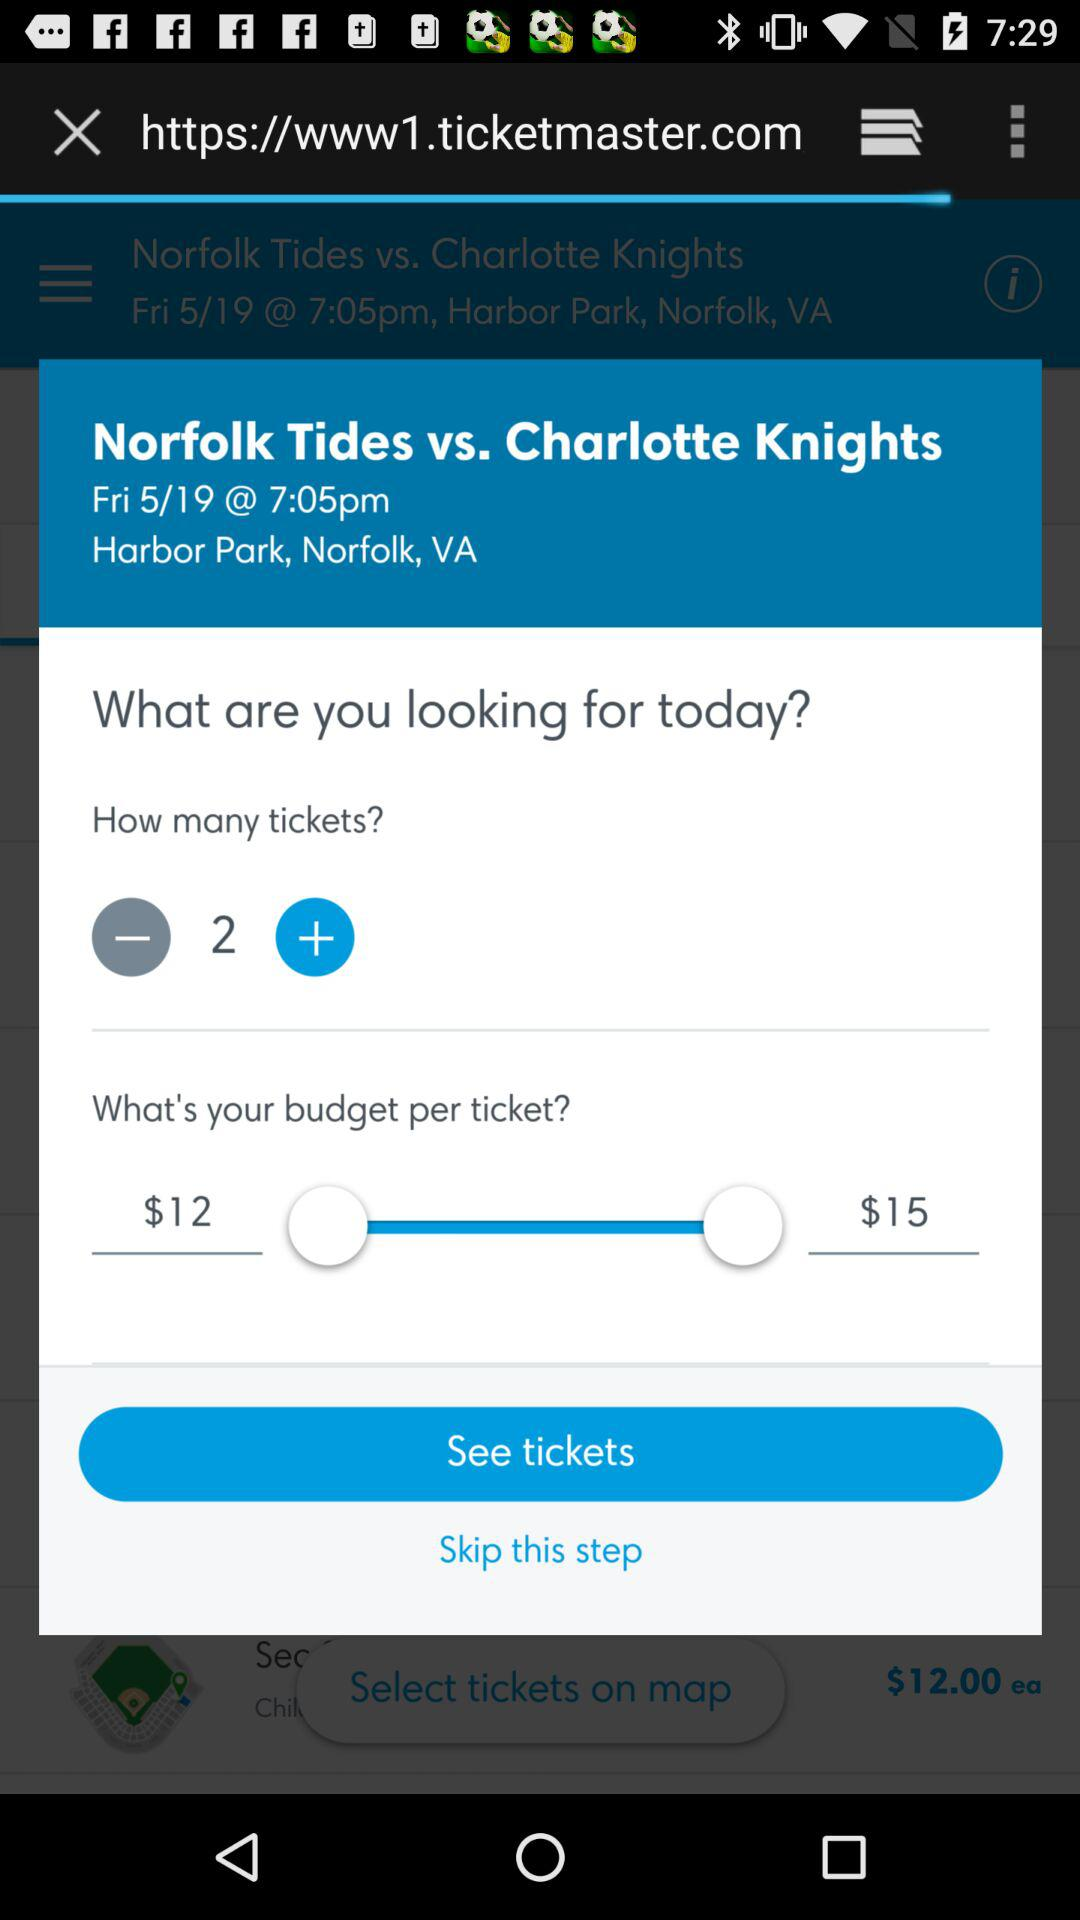What is the URL of the page? The URL of the page is https://www1.ticketmaster.com. 